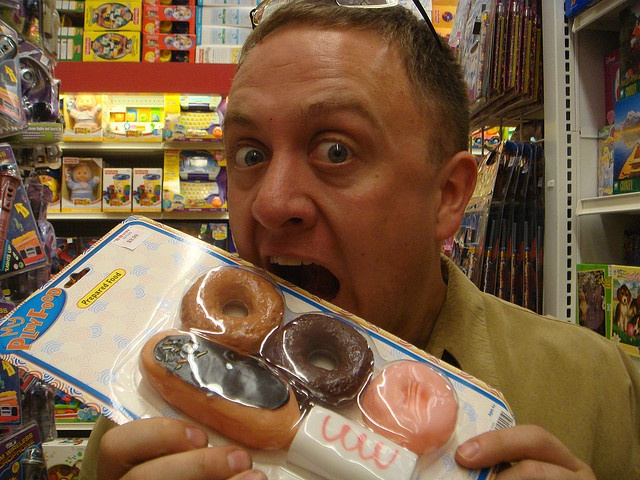Describe the objects in this image and their specific colors. I can see people in black, maroon, olive, brown, and gray tones, donut in black, brown, gray, and maroon tones, donut in black, maroon, and gray tones, donut in black, brown, gray, and maroon tones, and donut in black, salmon, and brown tones in this image. 